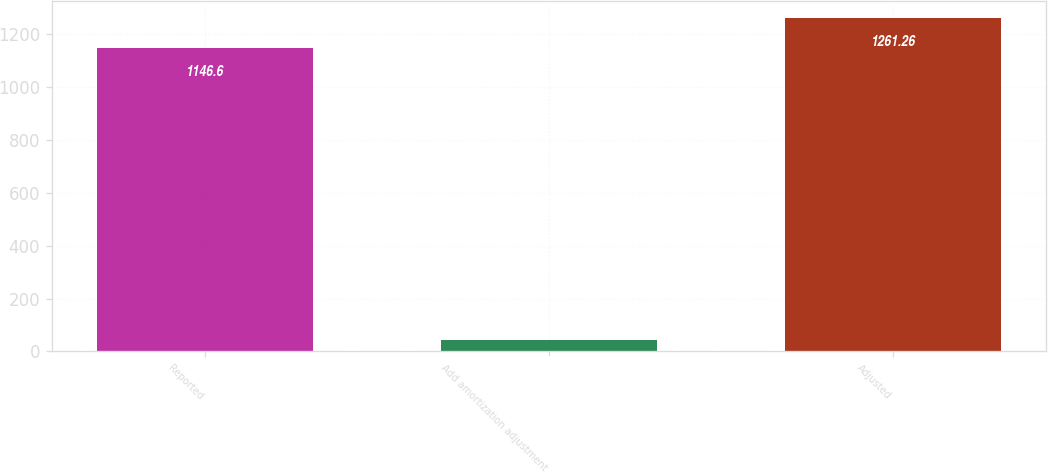Convert chart to OTSL. <chart><loc_0><loc_0><loc_500><loc_500><bar_chart><fcel>Reported<fcel>Add amortization adjustment<fcel>Adjusted<nl><fcel>1146.6<fcel>43.8<fcel>1261.26<nl></chart> 